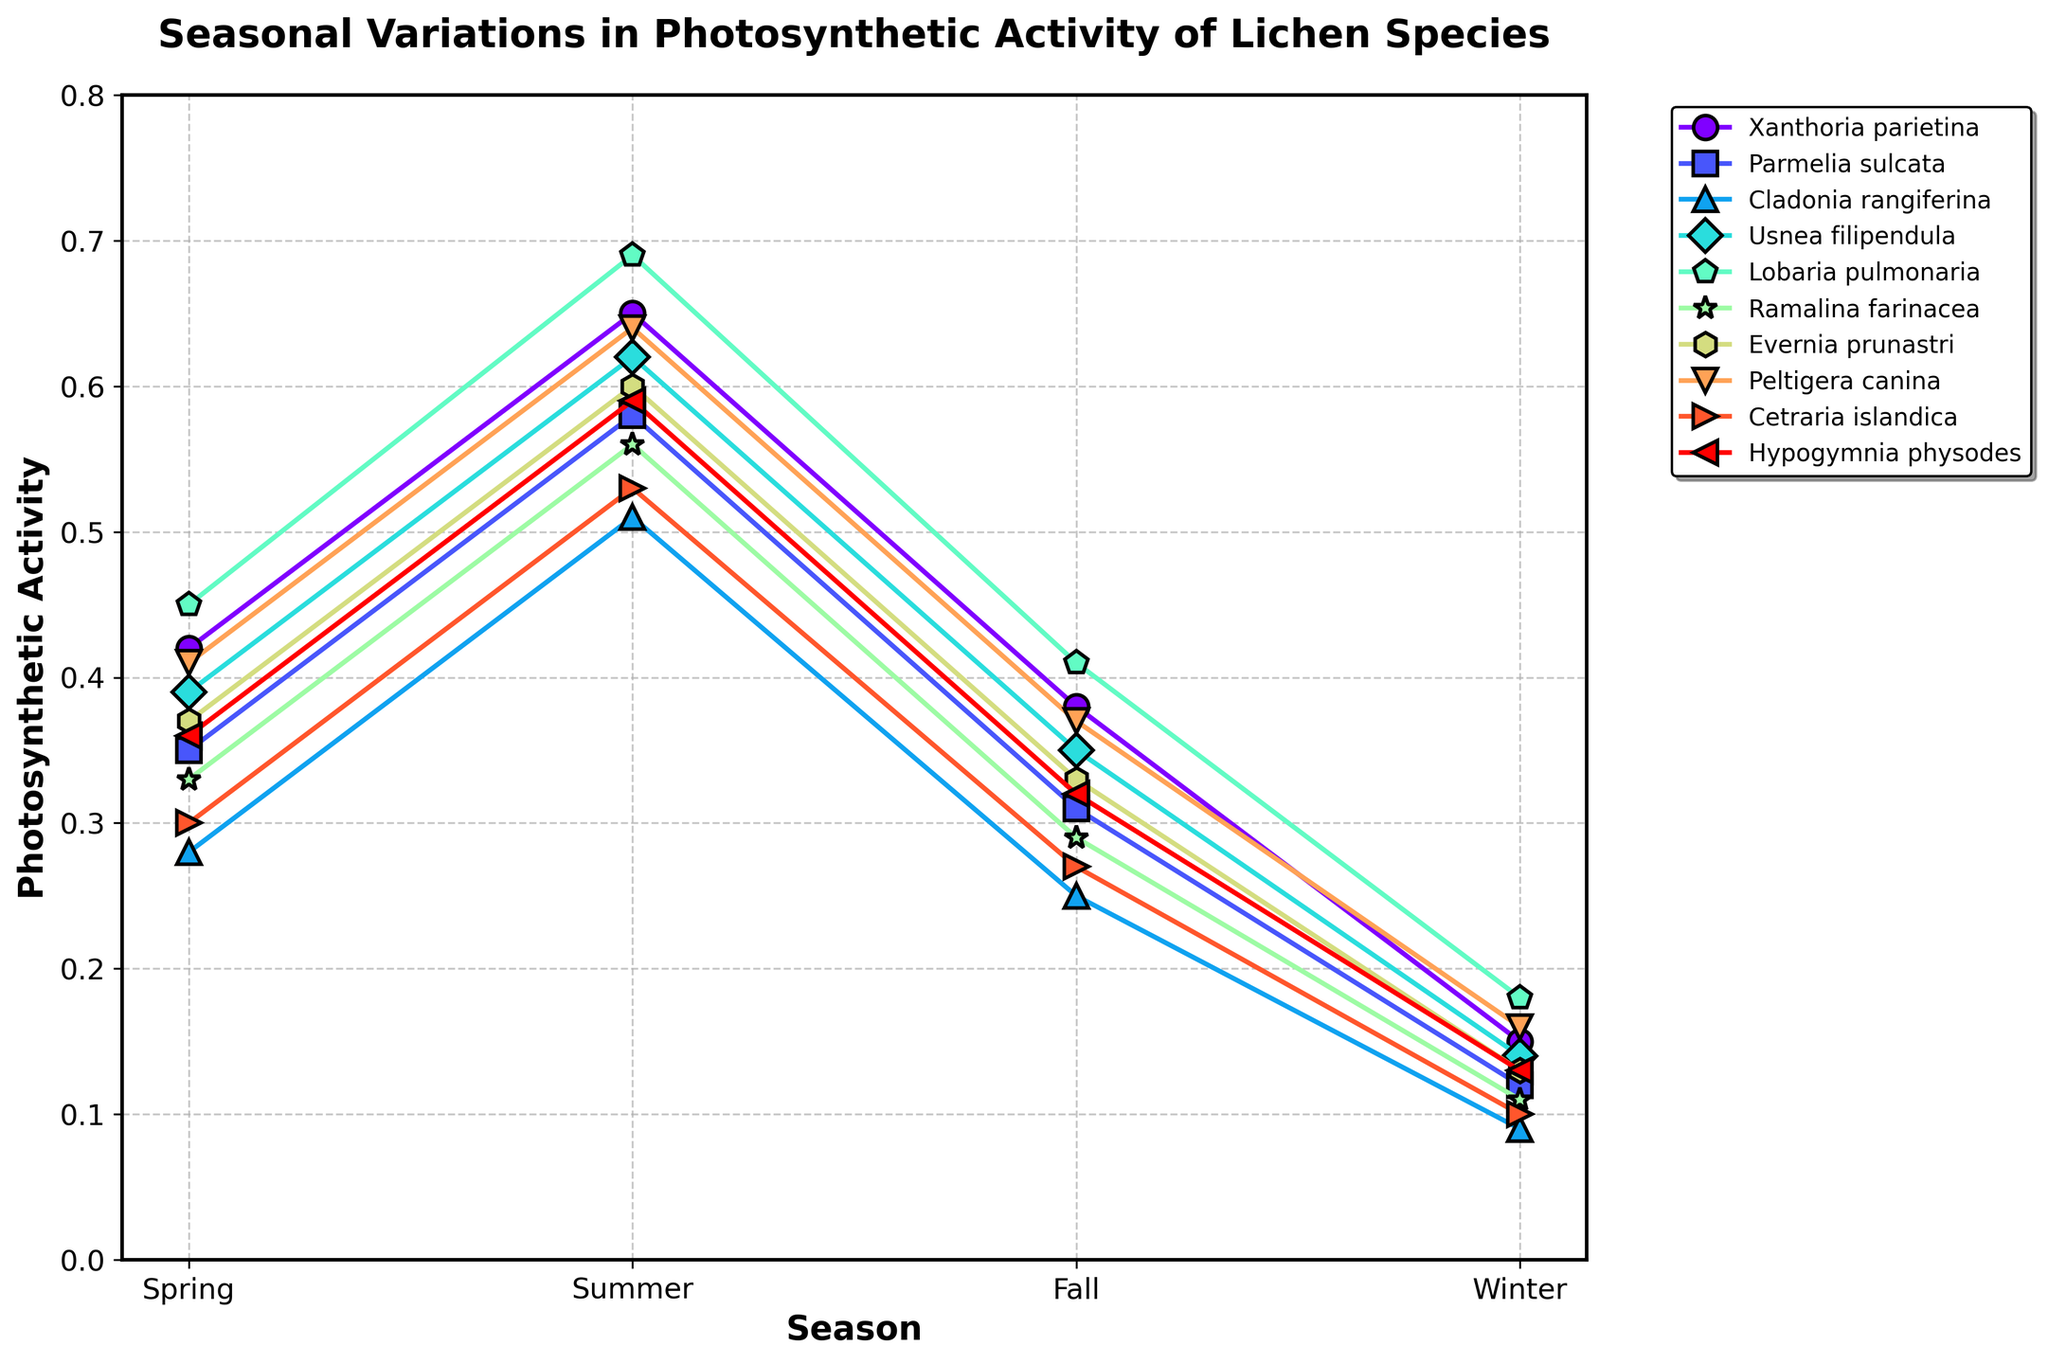Which lichen species exhibits the highest photosynthetic activity in Summer? The highest point on the y-axis for Summer corresponds to 'Lobaria pulmonaria'.
Answer: Lobaria pulmonaria Which season shows the lowest average photosynthetic activity across all lichen species? Calculate the average for each season: Spring = (Sum of Spring values from all species)/10; Summer = (Sum of Summer values from all species)/10; Fall = (Sum of Fall values from all species)/10; Winter = (Sum of Winter values from all species)/10. The lowest value is seen for Winter.
Answer: Winter Among Cladonia rangiferina and Xanthoria parietina, which species has a higher photosynthetic activity in Fall? Compare the Fall photosynthetic activity values: Cladonia rangiferina = 0.25, Xanthoria parietina = 0.38.
Answer: Xanthoria parietina What is the difference in photosynthetic activity between Spring and Winter for Evernia prunastri? Subtract Winter value from Spring value: 0.37 - 0.13.
Answer: 0.24 Which species shows the most consistent (least variation) photosynthetic activity across the seasons? Calculate the range (max-min) for each species: The species with the smallest range is the one with the most consistent activity. 'Hypogymnia physodes' has the least variation (0.59-0.36=0.23).
Answer: Hypogymnia physodes What is the combined photosynthetic activity of Usnea filipendula for Spring and Summer? Add Spring and Summer values for Usnea filipendula: 0.39 + 0.62.
Answer: 1.01 Which species shows a significant drop in photosynthetic activity from Summer to Fall? Compare Summer and Fall values for each species, looking for the largest decrease. 'Lobaria pulmonaria' has a drop of 0.69 - 0.41 = 0.28.
Answer: Lobaria pulmonaria How does photosynthetic activity in Winter for Peltigera canina compare to Ramalina farinacea? Compare Winter values: Peltigera canina = 0.16, Ramalina farinacea = 0.11.
Answer: Peltigera canina What is the average photosynthetic activity of all species in Spring? Sum up all Spring values and divide by the number of species (10).
Answer: 0.366 